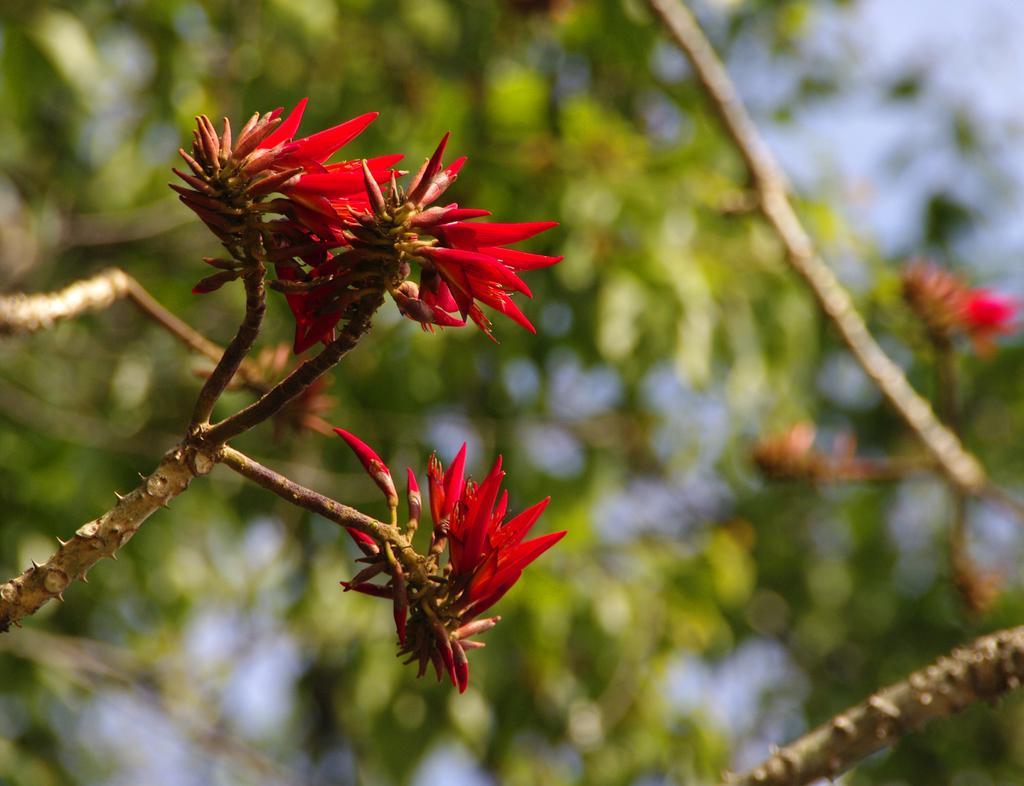Please provide a concise description of this image. This picture might be taken from outside of the city. In this image, on the left side, we can see some flowers, on which it stem is having some thorns. In the background, we can see some trees and flowers, we can also see sky in the background. 